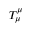Convert formula to latex. <formula><loc_0><loc_0><loc_500><loc_500>T _ { \mu } ^ { \mu }</formula> 